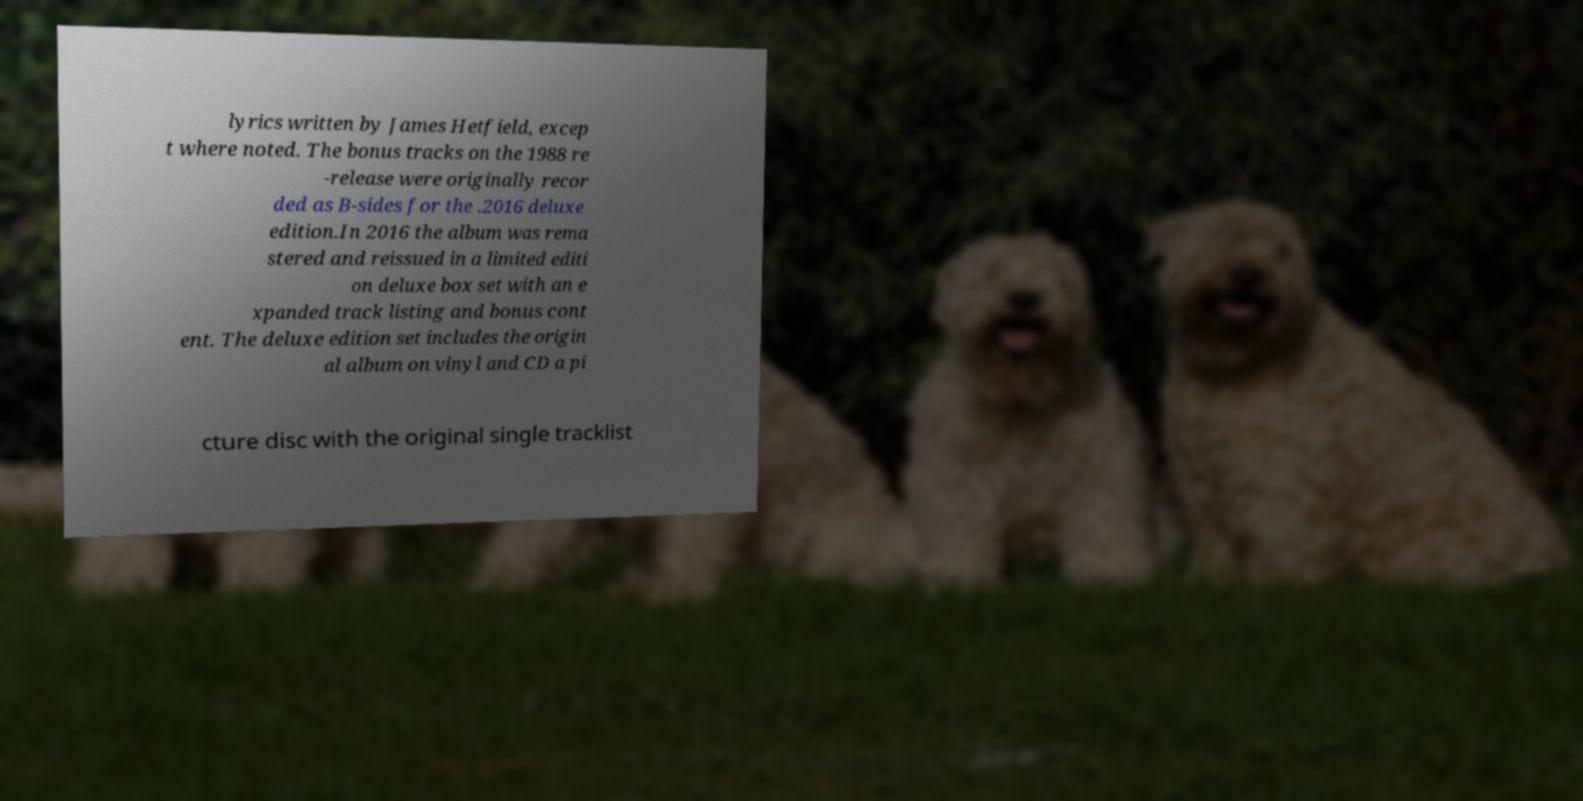For documentation purposes, I need the text within this image transcribed. Could you provide that? lyrics written by James Hetfield, excep t where noted. The bonus tracks on the 1988 re -release were originally recor ded as B-sides for the .2016 deluxe edition.In 2016 the album was rema stered and reissued in a limited editi on deluxe box set with an e xpanded track listing and bonus cont ent. The deluxe edition set includes the origin al album on vinyl and CD a pi cture disc with the original single tracklist 